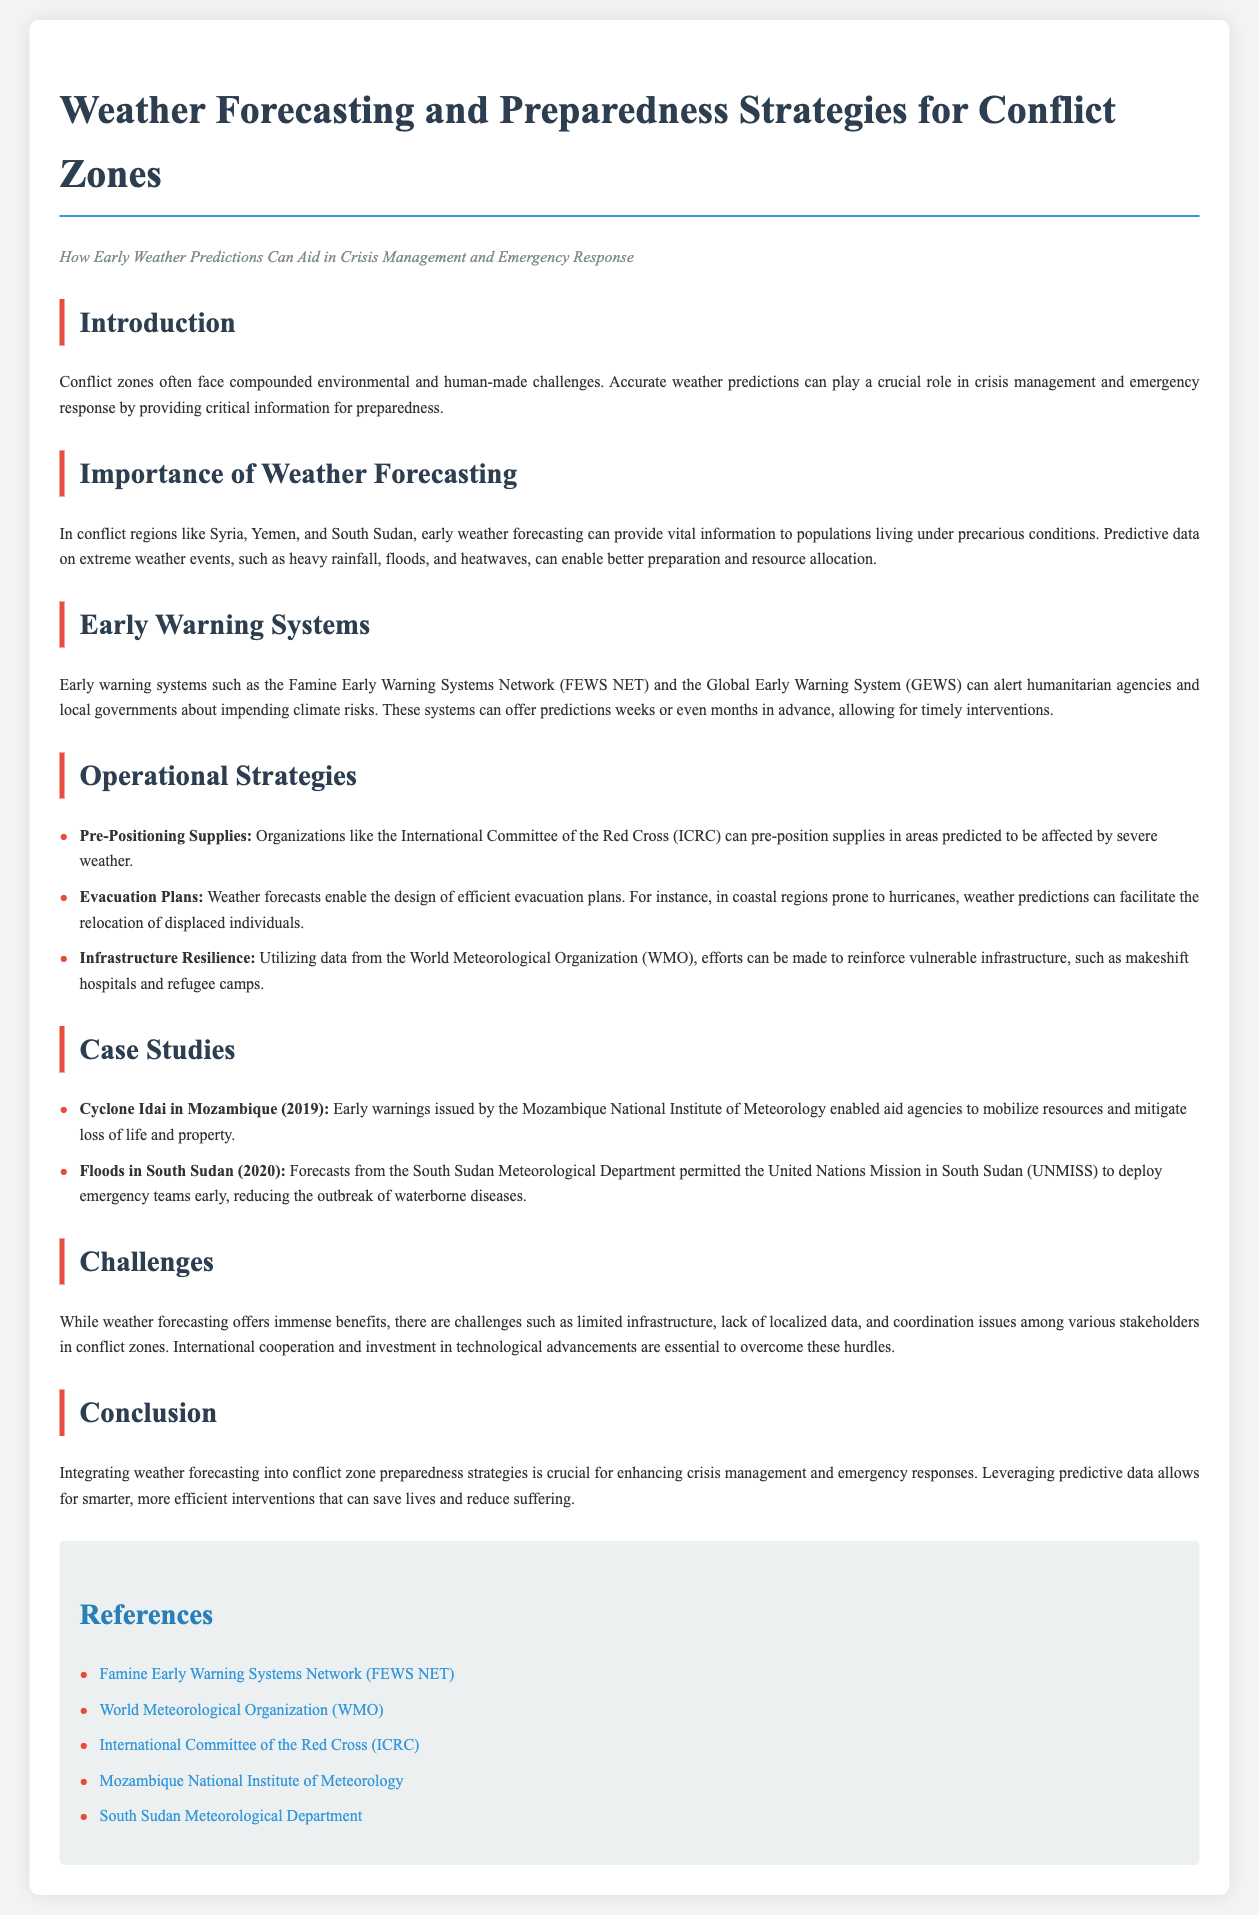What is the main title of the document? The title of the document is found at the top and highlights the focus on weather forecasting strategies in conflict zones.
Answer: Weather Forecasting and Preparedness Strategies for Conflict Zones Which early warning system is mentioned for aiding in crisis management? The document lists specific early warning systems that can alert agencies about climate risks, with one prominently featured.
Answer: Famine Early Warning Systems Network (FEWS NET) What major natural disaster is discussed in relation to Mozambique? The document cites a specific cyclone that impacted Mozambique and led to early warnings.
Answer: Cyclone Idai In what year did floods occur in South Sudan? The document specifies the year when significant floods took place in South Sudan that prompted emergency responses.
Answer: 2020 How can weather forecasting improve evacuation plans? The document explains the role of weather predictions in planning for movements during emergencies in certain regions.
Answer: Design of efficient evacuation plans What type of organizations can pre-position supplies according to the document? The text refers to specific humanitarian organizations that undertake the action of storing supplies ahead of predicted weather events.
Answer: International Committee of the Red Cross (ICRC) What is a challenge mentioned regarding weather forecasting in conflict zones? The document lists challenges faced in implementing effective weather forecasting and emergency responses, one of which is crucial for success.
Answer: Limited infrastructure What benefit does early weather forecasting provide to populations in conflict zones? The document outlines the positive outcomes of having accurate weather predictions, especially for vulnerable populations amidst conflict.
Answer: Vital information for preparedness 